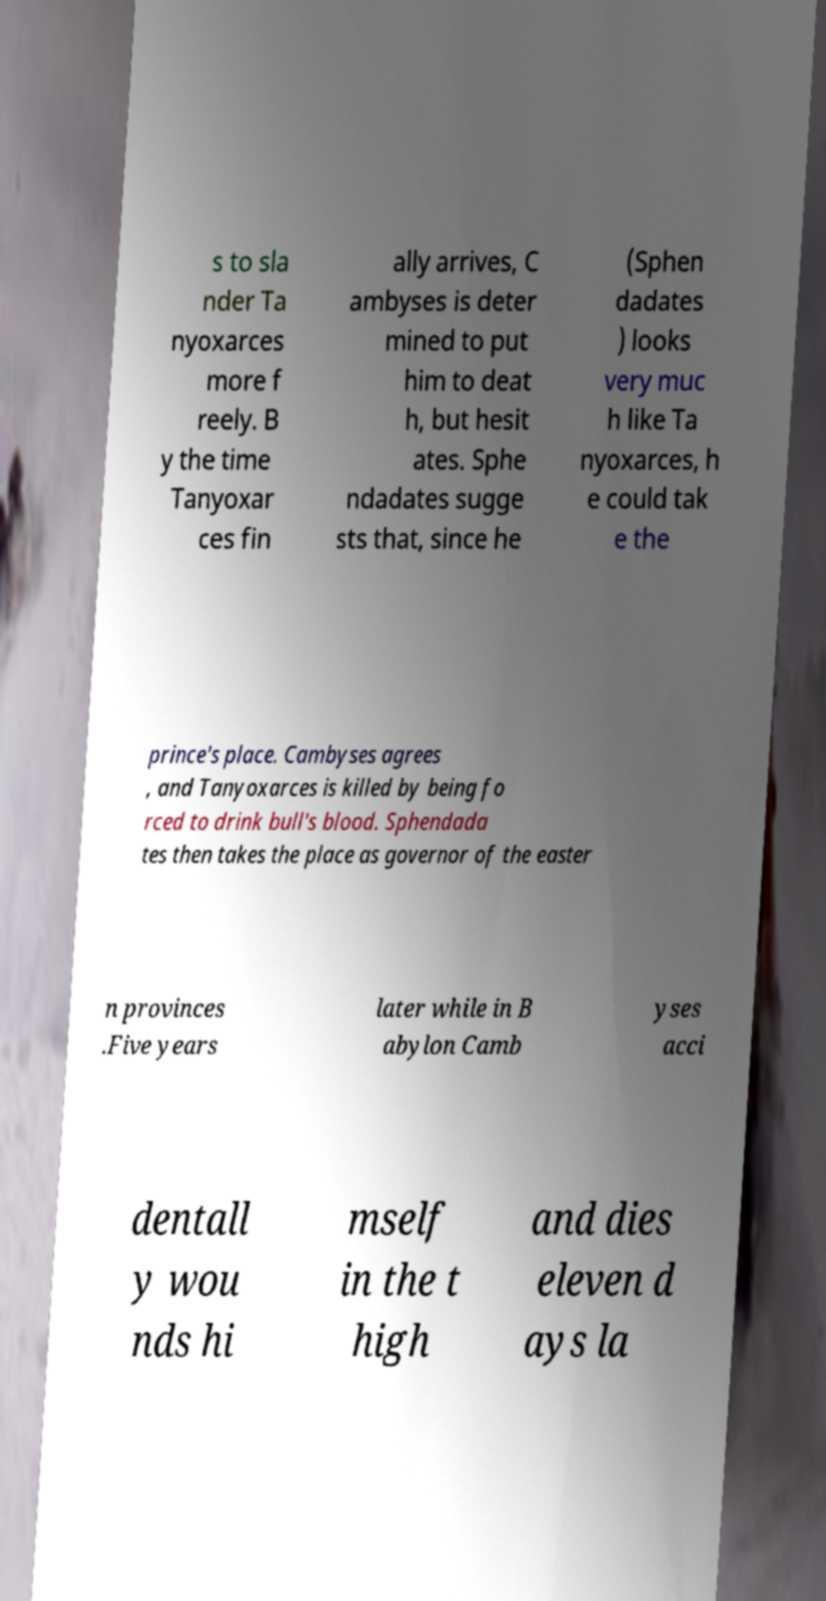Please read and relay the text visible in this image. What does it say? s to sla nder Ta nyoxarces more f reely. B y the time Tanyoxar ces fin ally arrives, C ambyses is deter mined to put him to deat h, but hesit ates. Sphe ndadates sugge sts that, since he (Sphen dadates ) looks very muc h like Ta nyoxarces, h e could tak e the prince's place. Cambyses agrees , and Tanyoxarces is killed by being fo rced to drink bull's blood. Sphendada tes then takes the place as governor of the easter n provinces .Five years later while in B abylon Camb yses acci dentall y wou nds hi mself in the t high and dies eleven d ays la 